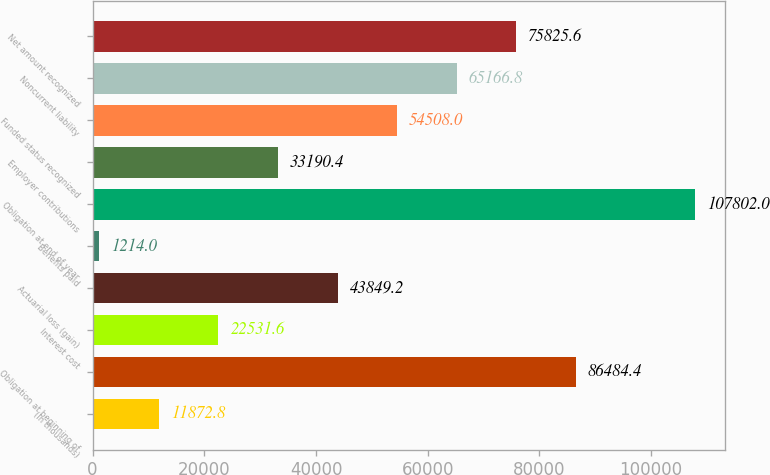<chart> <loc_0><loc_0><loc_500><loc_500><bar_chart><fcel>(In thousands)<fcel>Obligation at beginning of<fcel>Interest cost<fcel>Actuarial loss (gain)<fcel>Benefits paid<fcel>Obligation at end of year<fcel>Employer contributions<fcel>Funded status recognized<fcel>Noncurrent liability<fcel>Net amount recognized<nl><fcel>11872.8<fcel>86484.4<fcel>22531.6<fcel>43849.2<fcel>1214<fcel>107802<fcel>33190.4<fcel>54508<fcel>65166.8<fcel>75825.6<nl></chart> 